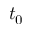Convert formula to latex. <formula><loc_0><loc_0><loc_500><loc_500>t _ { 0 }</formula> 